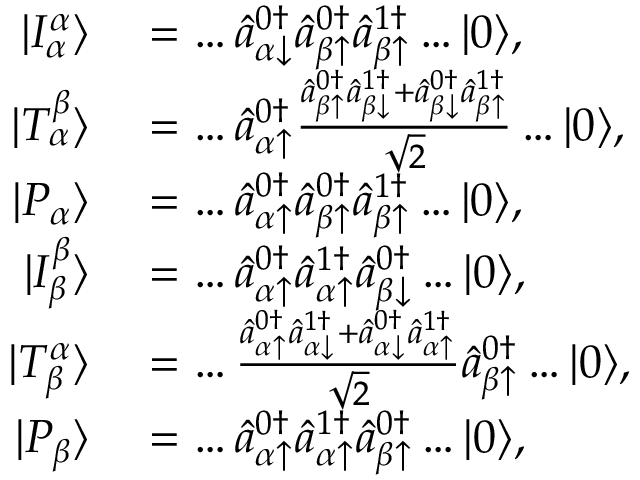Convert formula to latex. <formula><loc_0><loc_0><loc_500><loc_500>\begin{array} { r l } { | I _ { \alpha } ^ { \alpha } \rangle } & = \dots \hat { a } _ { \alpha \downarrow } ^ { 0 \dagger } \hat { a } _ { \beta \uparrow } ^ { 0 \dagger } \hat { a } _ { \beta \uparrow } ^ { 1 \dagger } \dots | 0 \rangle , } \\ { | T _ { \alpha } ^ { \beta } \rangle } & = \dots \hat { a } _ { \alpha \uparrow } ^ { 0 \dagger } \frac { \hat { a } _ { \beta \uparrow } ^ { 0 \dagger } \hat { a } _ { \beta \downarrow } ^ { 1 \dagger } + \hat { a } _ { \beta \downarrow } ^ { 0 \dagger } \hat { a } _ { \beta \uparrow } ^ { 1 \dagger } } { \sqrt { 2 } } \dots | 0 \rangle , } \\ { | P _ { \alpha } \rangle } & = \dots \hat { a } _ { \alpha \uparrow } ^ { 0 \dagger } \hat { a } _ { \beta \uparrow } ^ { 0 \dagger } \hat { a } _ { \beta \uparrow } ^ { 1 \dagger } \dots | 0 \rangle , } \\ { | I _ { \beta } ^ { \beta } \rangle } & = \dots \hat { a } _ { \alpha \uparrow } ^ { 0 \dagger } \hat { a } _ { \alpha \uparrow } ^ { 1 \dagger } \hat { a } _ { \beta \downarrow } ^ { 0 \dagger } \dots | 0 \rangle , } \\ { | T _ { \beta } ^ { \alpha } \rangle } & = \dots \frac { \hat { a } _ { \alpha \uparrow } ^ { 0 \dagger } \hat { a } _ { \alpha \downarrow } ^ { 1 \dagger } + \hat { a } _ { \alpha \downarrow } ^ { 0 \dagger } \hat { a } _ { \alpha \uparrow } ^ { 1 \dagger } } { \sqrt { 2 } } \hat { a } _ { \beta \uparrow } ^ { 0 \dagger } \dots | 0 \rangle , } \\ { | P _ { \beta } \rangle } & = \dots \hat { a } _ { \alpha \uparrow } ^ { 0 \dagger } \hat { a } _ { \alpha \uparrow } ^ { 1 \dagger } \hat { a } _ { \beta \uparrow } ^ { 0 \dagger } \dots | 0 \rangle , } \end{array}</formula> 